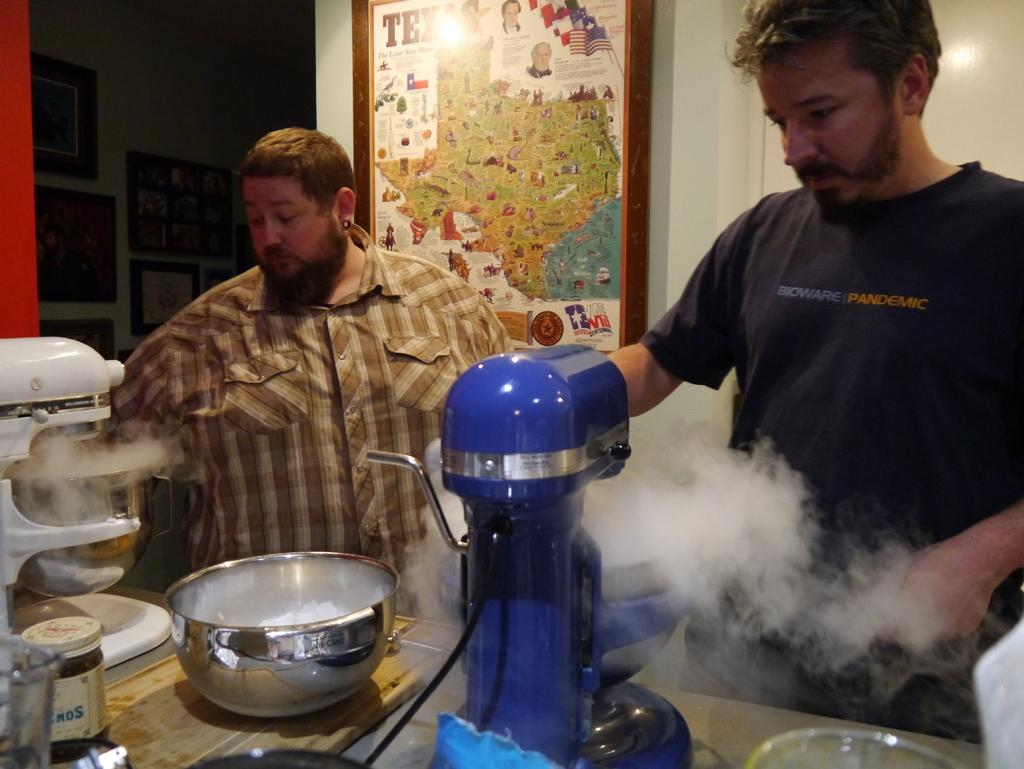<image>
Create a compact narrative representing the image presented. a man wearing a Bioware  Pandemic tshirt cooking with another man 